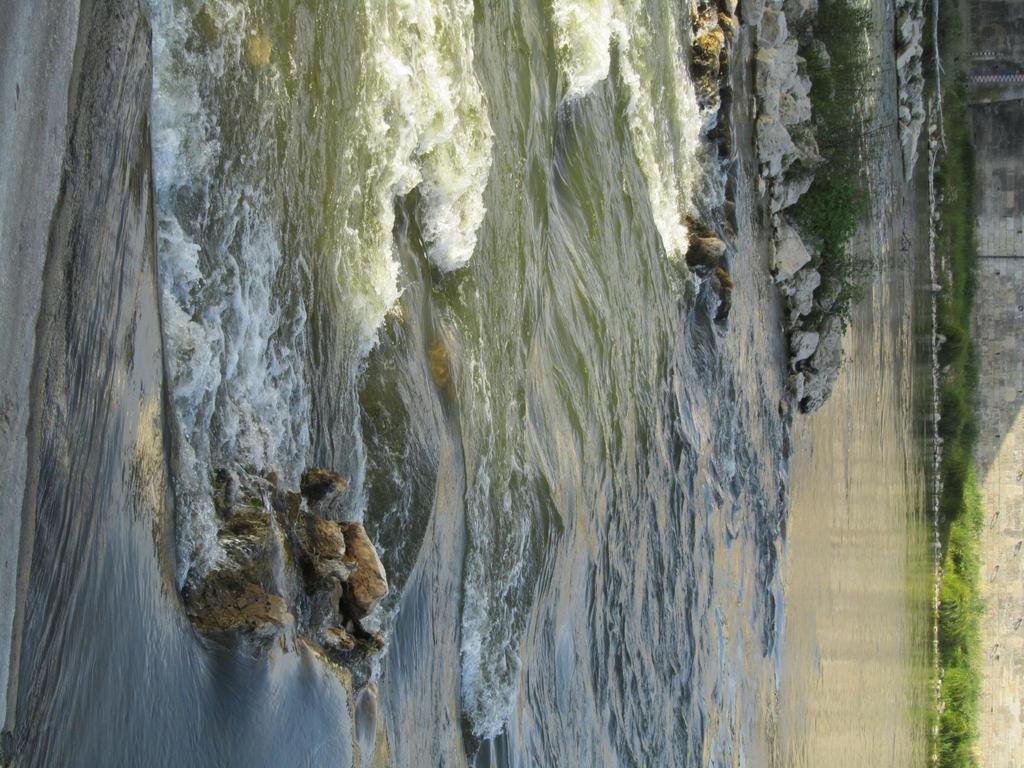Can you describe this image briefly? In the image there is a lake with some stones in the middle and in the back there is a wall with plants in front of it. 